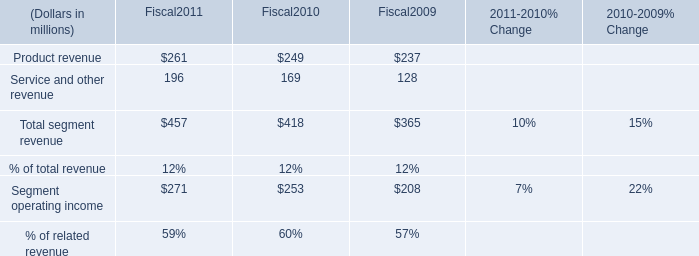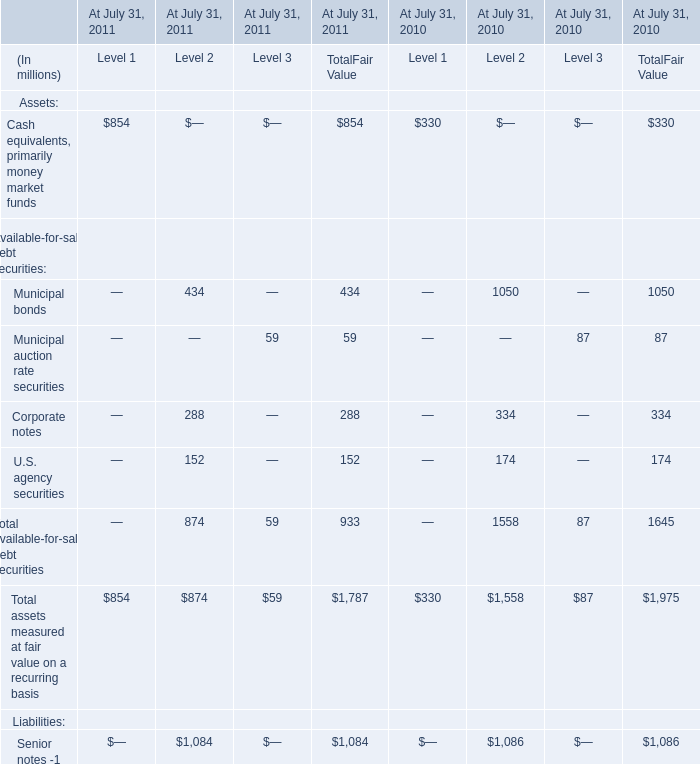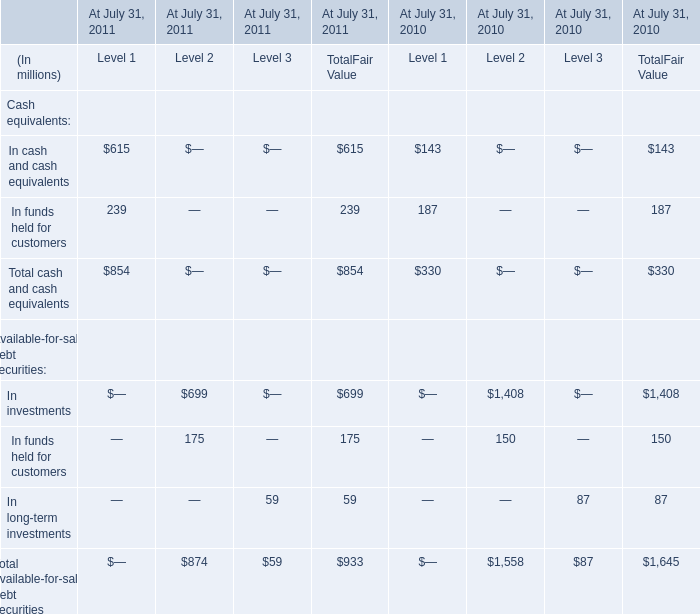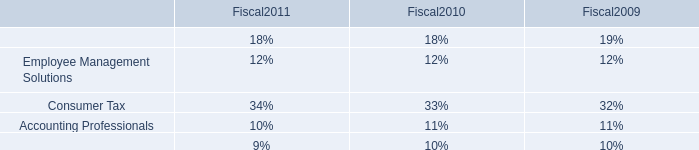In the year with the most Cash equivalents, primarily money market funds for TotalFair Value, what is the growth rate of Corporate notes for TotalFair Value? 
Computations: ((288 - 334) / 334)
Answer: -0.13772. What do all Level 1 sum up without those Level 1 smaller than 250, in 2011? (in million) 
Computations: (615 + 854)
Answer: 1469.0. 